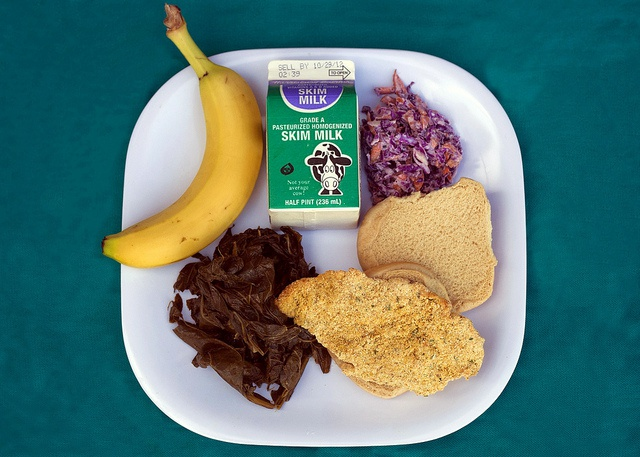Describe the objects in this image and their specific colors. I can see dining table in teal, lightgray, tan, black, and darkgray tones, sandwich in teal, tan, khaki, and olive tones, banana in teal, orange, gold, and olive tones, and sandwich in teal and tan tones in this image. 